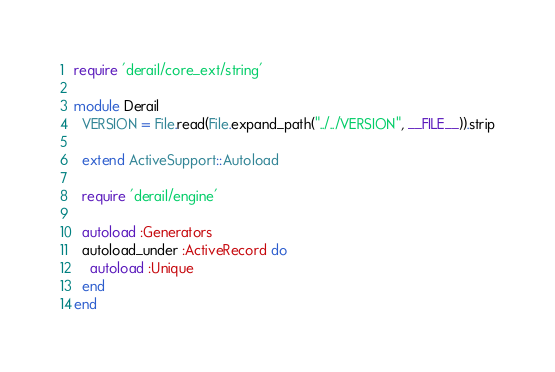<code> <loc_0><loc_0><loc_500><loc_500><_Ruby_>require 'derail/core_ext/string'

module Derail
  VERSION = File.read(File.expand_path("../../VERSION", __FILE__)).strip

  extend ActiveSupport::Autoload

  require 'derail/engine'

  autoload :Generators
  autoload_under :ActiveRecord do
    autoload :Unique
  end
end

</code> 